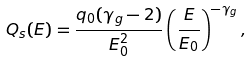Convert formula to latex. <formula><loc_0><loc_0><loc_500><loc_500>Q _ { s } ( E ) = \frac { q _ { 0 } ( \gamma _ { g } - 2 ) } { E _ { 0 } ^ { 2 } } \left ( \frac { E } { E _ { 0 } } \right ) ^ { - \gamma _ { g } } ,</formula> 